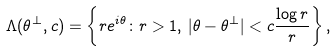<formula> <loc_0><loc_0><loc_500><loc_500>\Lambda ( \theta ^ { \bot } , c ) = \left \{ r e ^ { i \theta } \colon r > 1 , \, | \theta - \theta ^ { \bot } | < c \frac { \log r } { r } \right \} ,</formula> 